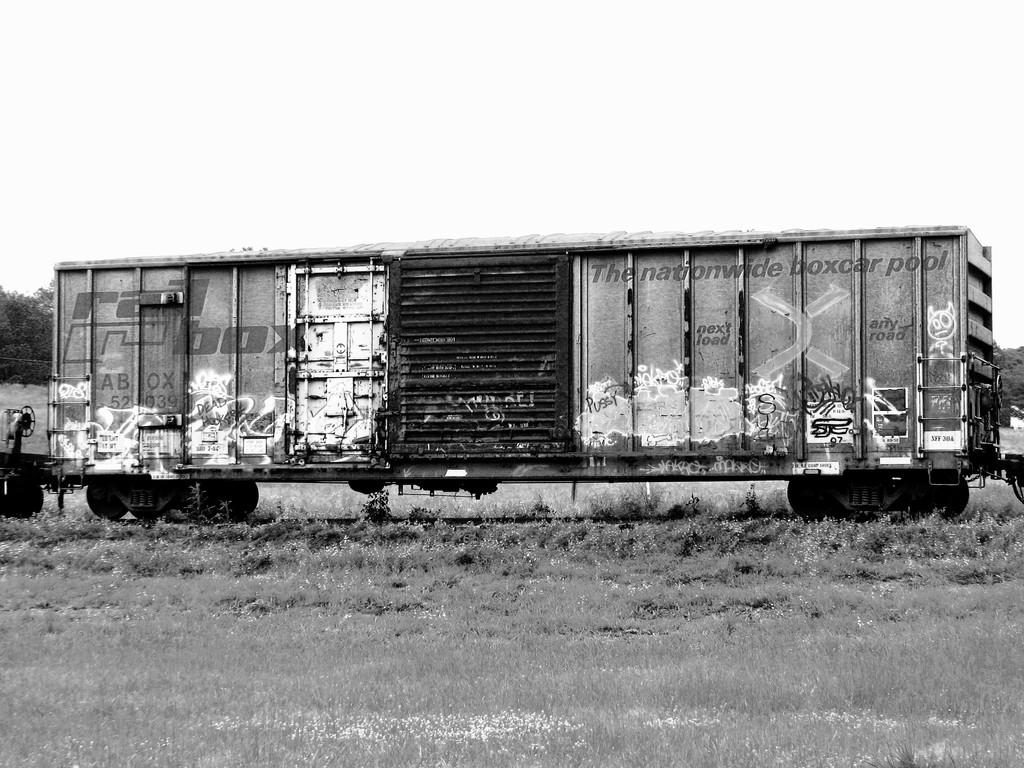What is the color scheme of the image? The image is black and white. What is the main subject of the image? There is a train blog in the image. Where is the train blog located? The train blog is on a railway track. What can be seen in the background of the image? There is grass, trees, and the sky visible in the background of the image. What type of education is being provided by the airplane in the image? There is no airplane present in the image, so no education is being provided by an airplane. Where is the faucet located in the image? There is no faucet present in the image. 